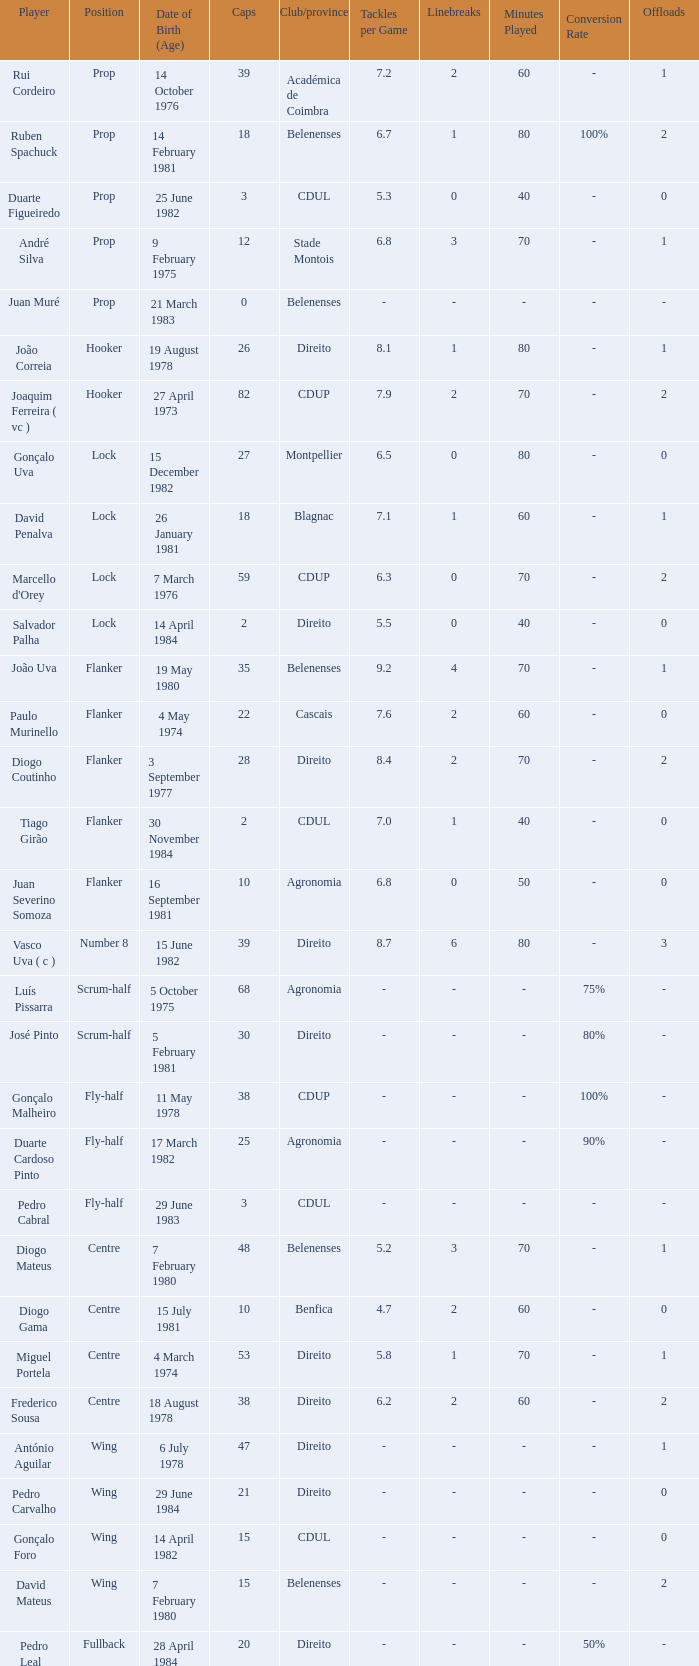What is the count of caps with a date of birth (age) on july 15, 1981? 1.0. 